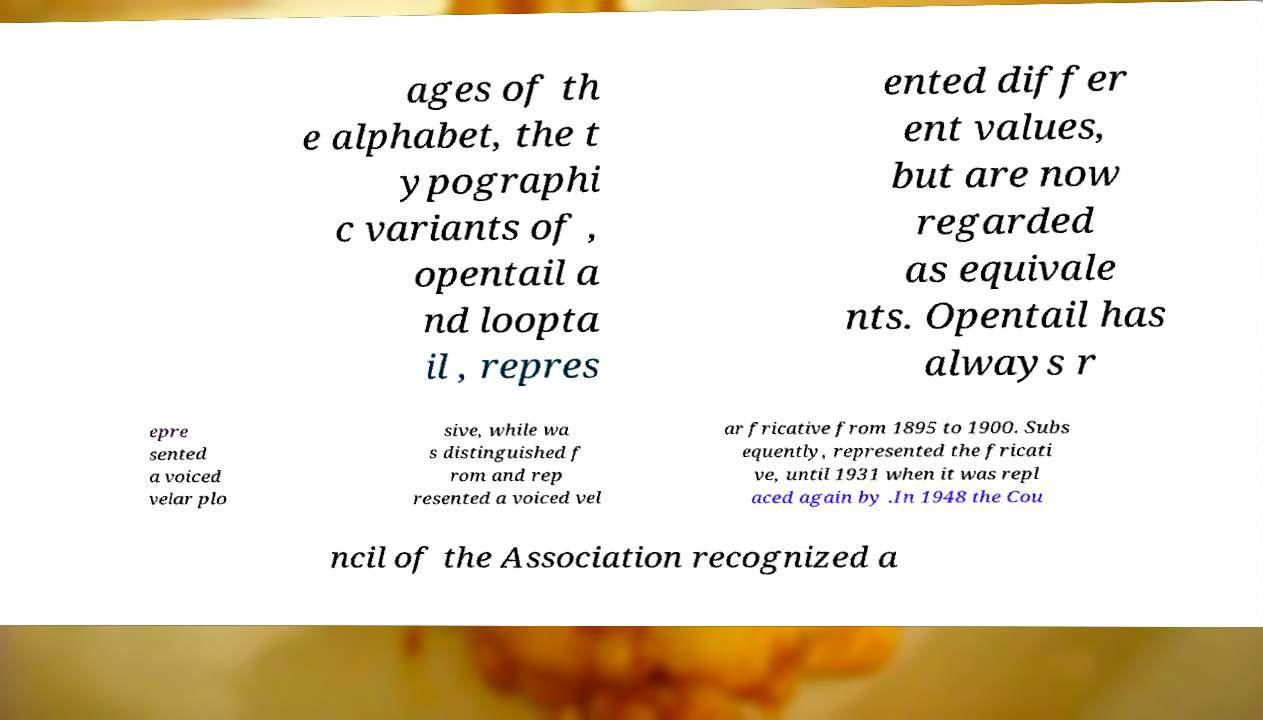Please identify and transcribe the text found in this image. ages of th e alphabet, the t ypographi c variants of , opentail a nd loopta il , repres ented differ ent values, but are now regarded as equivale nts. Opentail has always r epre sented a voiced velar plo sive, while wa s distinguished f rom and rep resented a voiced vel ar fricative from 1895 to 1900. Subs equently, represented the fricati ve, until 1931 when it was repl aced again by .In 1948 the Cou ncil of the Association recognized a 